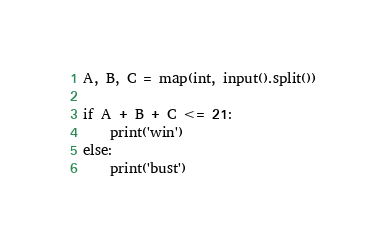<code> <loc_0><loc_0><loc_500><loc_500><_Python_>A, B, C = map(int, input().split())

if A + B + C <= 21:
    print('win')
else:
    print('bust')</code> 